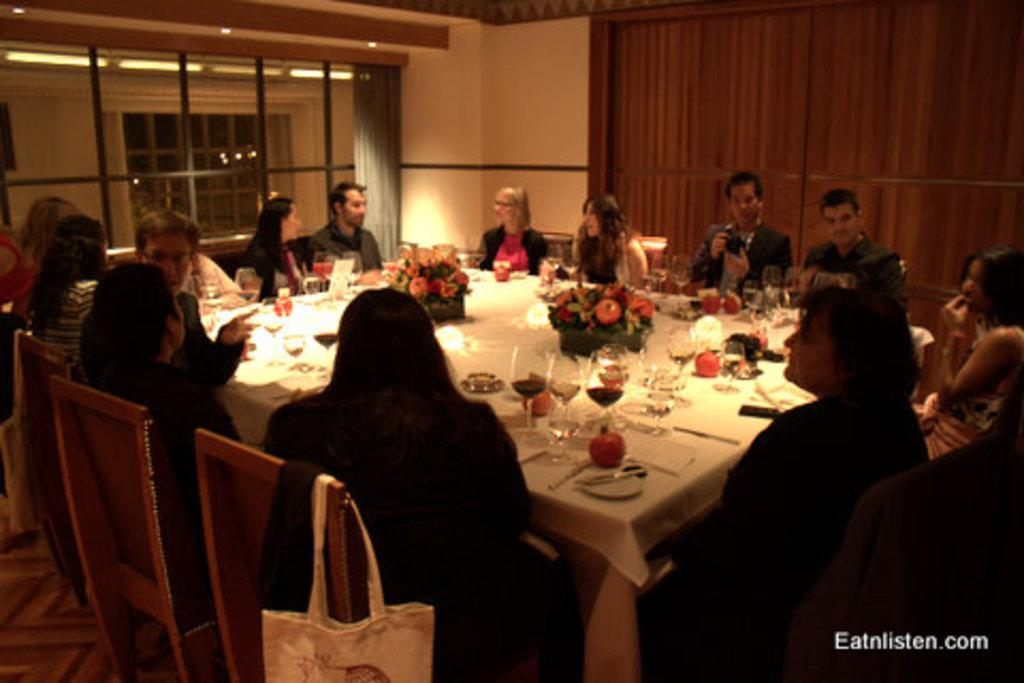How many people are in the image? There is a group of people in the image, but the exact number is not specified. What are the people doing in the image? The people are sitting around a white table. What can be found on the table in the image? There are eatables and drinks on the table. What type of plane can be seen flying over the table in the image? There is no plane visible in the image; it only shows a group of people sitting around a table with eatables and drinks. 